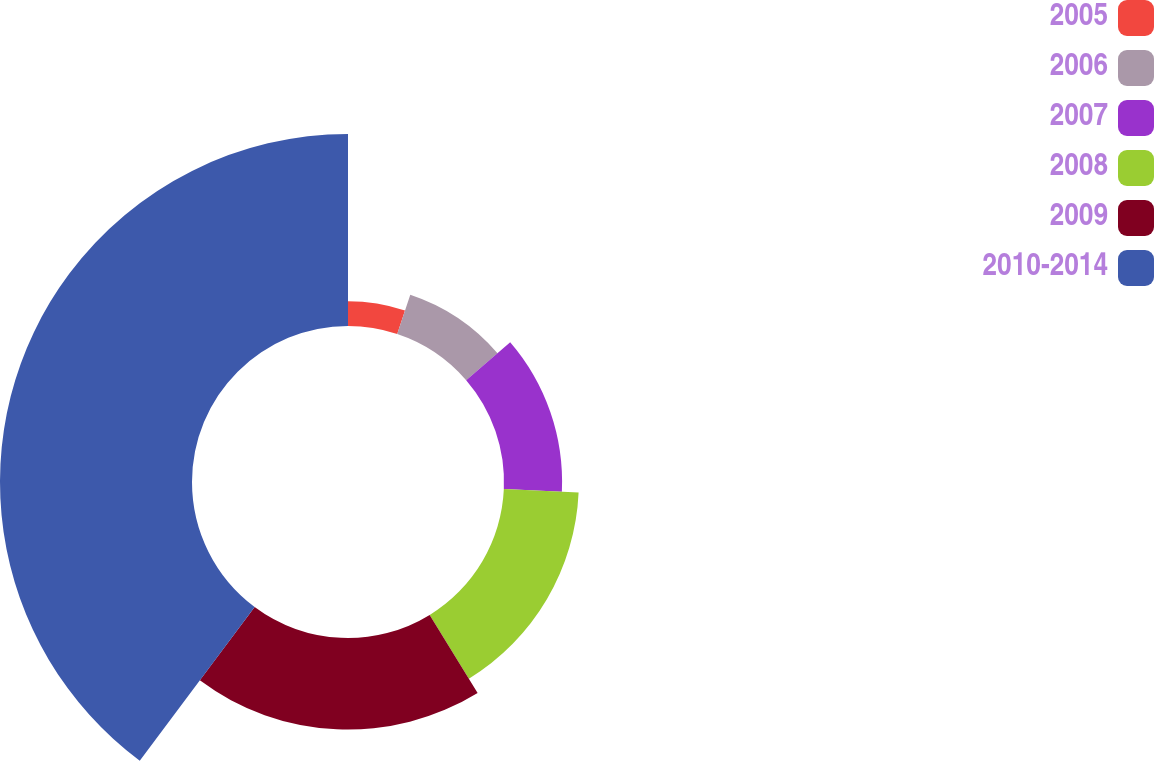Convert chart. <chart><loc_0><loc_0><loc_500><loc_500><pie_chart><fcel>2005<fcel>2006<fcel>2007<fcel>2008<fcel>2009<fcel>2010-2014<nl><fcel>5.11%<fcel>8.57%<fcel>12.04%<fcel>15.51%<fcel>18.98%<fcel>39.79%<nl></chart> 